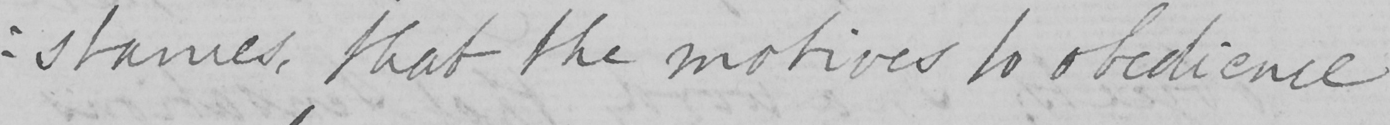Transcribe the text shown in this historical manuscript line. : stances , that the motives to obedience 